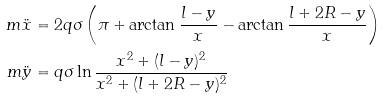<formula> <loc_0><loc_0><loc_500><loc_500>m \ddot { x } & = 2 q \sigma \left ( \pi + \arctan { \frac { l - y } { x } } - \arctan { \frac { l + 2 R - y } { x } } \right ) \\ m \ddot { y } & = q \sigma \ln \frac { x ^ { 2 } + ( l - y ) ^ { 2 } } { x ^ { 2 } + ( l + 2 R - y ) ^ { 2 } }</formula> 